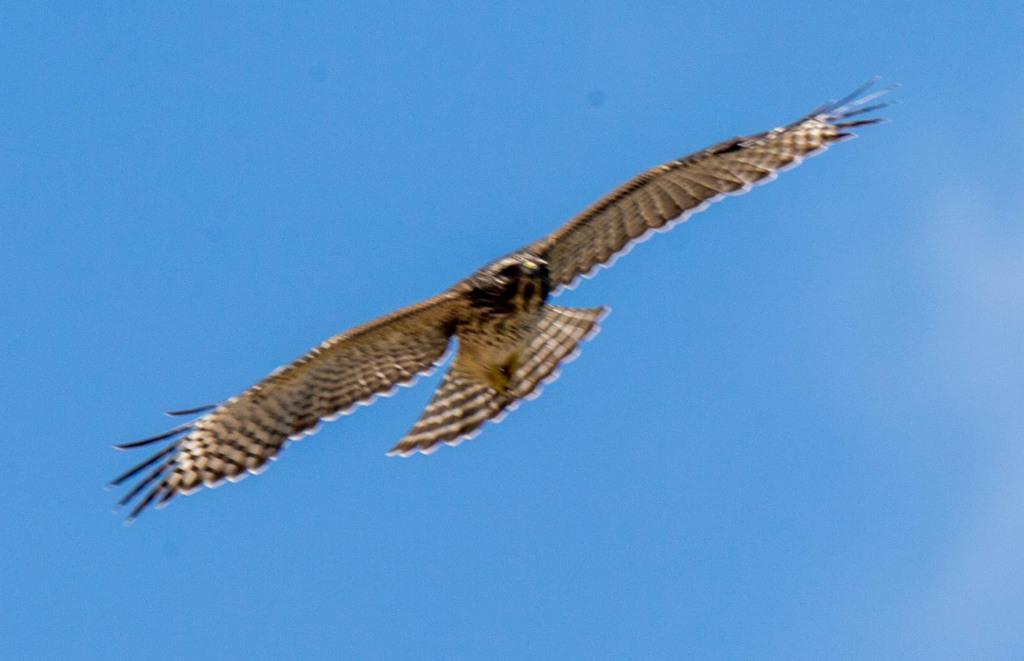How would you summarize this image in a sentence or two? There is a bird in black and white color combination, flying in the air. In the background, there is a blue sky. 